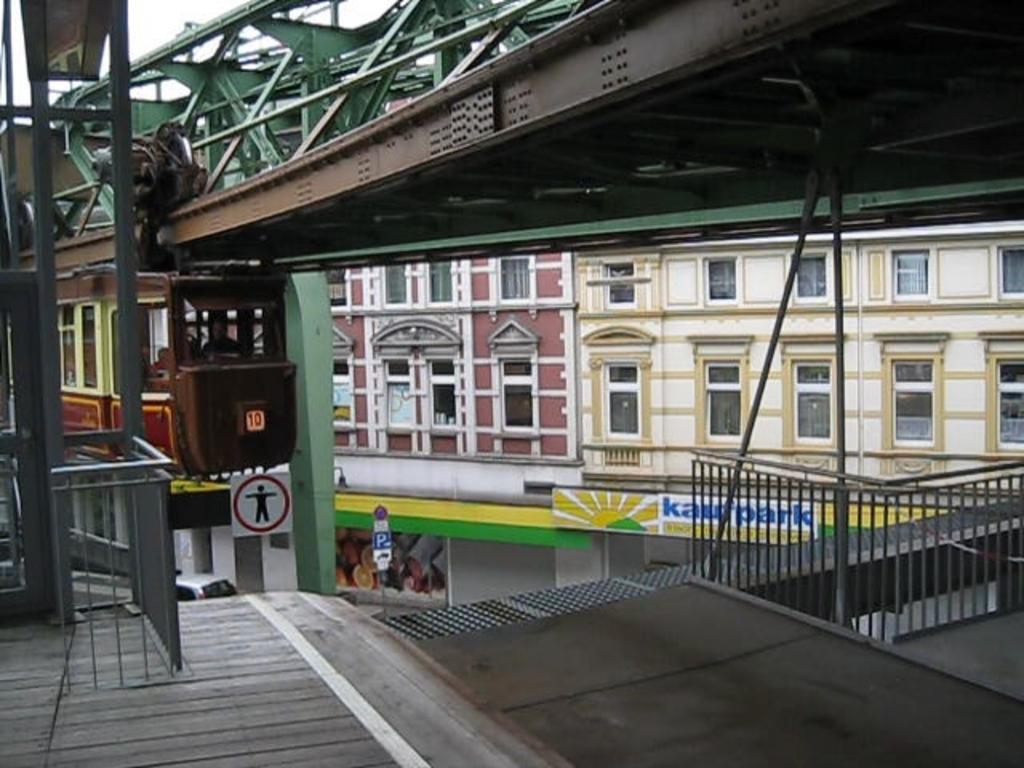In one or two sentences, can you explain what this image depicts? in this picture there is a bridge at the top side of the image and there is a tower on the left side of the image and there is a boundary on the right side of the image and there are buildings in the background area of the image, there are windows on the buildings and there are shops at the bottom side of the image. 